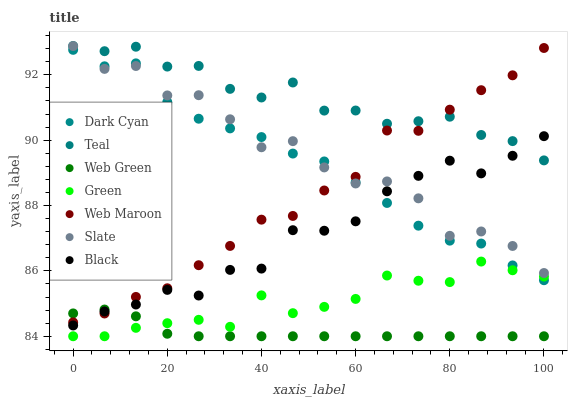Does Web Green have the minimum area under the curve?
Answer yes or no. Yes. Does Teal have the maximum area under the curve?
Answer yes or no. Yes. Does Web Maroon have the minimum area under the curve?
Answer yes or no. No. Does Web Maroon have the maximum area under the curve?
Answer yes or no. No. Is Web Green the smoothest?
Answer yes or no. Yes. Is Slate the roughest?
Answer yes or no. Yes. Is Web Maroon the smoothest?
Answer yes or no. No. Is Web Maroon the roughest?
Answer yes or no. No. Does Web Green have the lowest value?
Answer yes or no. Yes. Does Web Maroon have the lowest value?
Answer yes or no. No. Does Teal have the highest value?
Answer yes or no. Yes. Does Web Maroon have the highest value?
Answer yes or no. No. Is Web Green less than Slate?
Answer yes or no. Yes. Is Teal greater than Web Green?
Answer yes or no. Yes. Does Black intersect Web Maroon?
Answer yes or no. Yes. Is Black less than Web Maroon?
Answer yes or no. No. Is Black greater than Web Maroon?
Answer yes or no. No. Does Web Green intersect Slate?
Answer yes or no. No. 